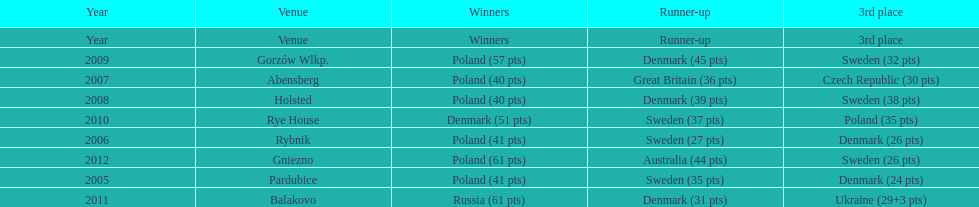From 2005-2012, in the team speedway junior world championship, how many more first place wins than all other teams put together? Poland. 